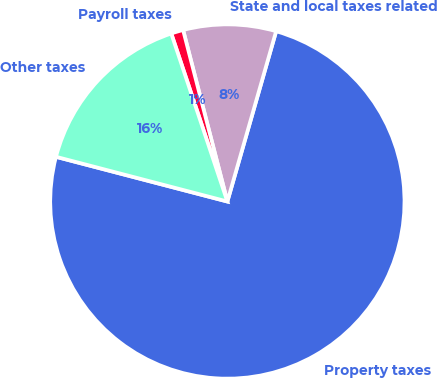Convert chart. <chart><loc_0><loc_0><loc_500><loc_500><pie_chart><fcel>Property taxes<fcel>State and local taxes related<fcel>Payroll taxes<fcel>Other taxes<nl><fcel>74.63%<fcel>8.46%<fcel>1.11%<fcel>15.81%<nl></chart> 